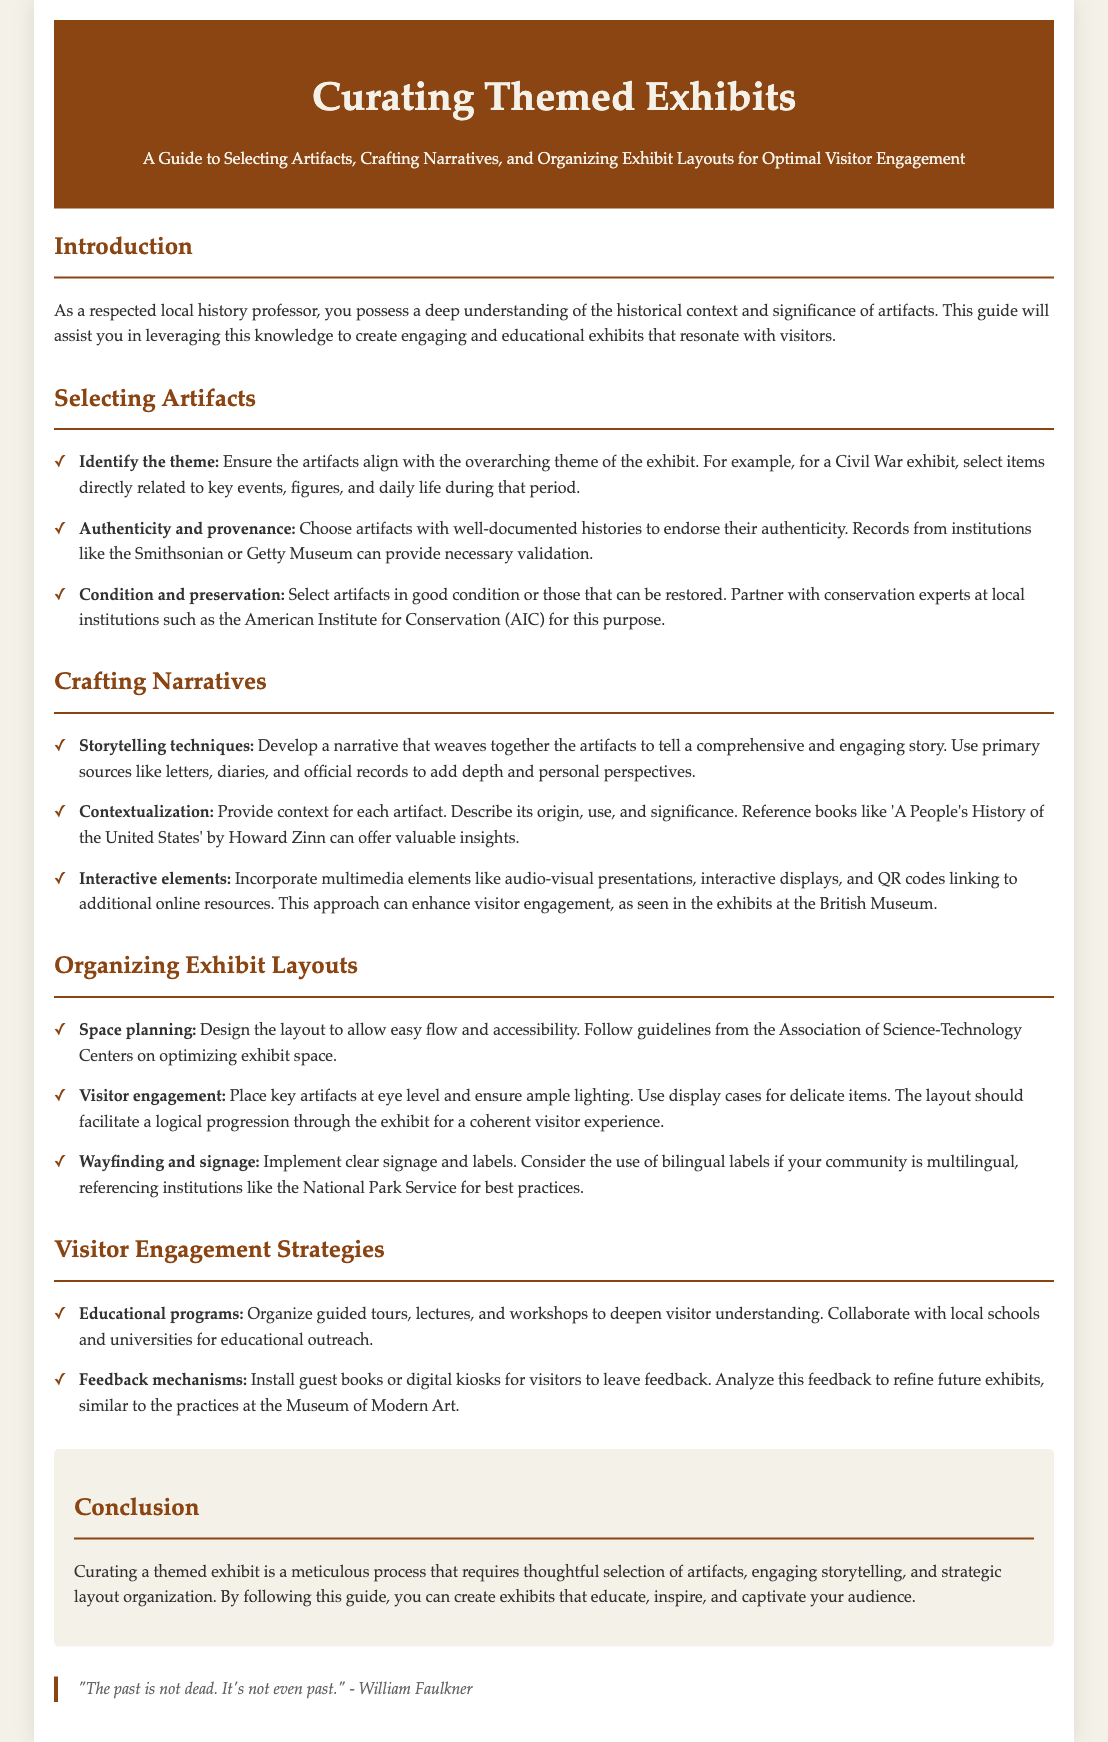what is the title of the guide? The title of the guide is the primary heading of the document, focusing on curating themed exhibits.
Answer: Curating Themed Exhibits what is one element to consider when selecting artifacts? The document lists several considerations for selecting artifacts, including authenticity, provenance, and condition.
Answer: Authenticity and provenance which author is referenced for insights on contextualization? The document mentions an author who wrote a related book for valuable insights into contextualizing artifacts.
Answer: Howard Zinn what type of strategies should be organized for visitor engagement? The document discusses various methods to enhance visitor engagement through educational efforts.
Answer: Educational programs what is the purpose of clear signage and labels? The guide explains the importance of signage in facilitating the exhibit's flow and understanding.
Answer: Wayfinding and signage how many key areas are emphasized in curating exhibits? The document outlines specific key areas involving artifacts, narratives, and layout organization in curating exhibits.
Answer: Three name one institution referenced for conservation expertise. The guide suggests partnering with specialized institutions for expert insights into artifact preservation.
Answer: American Institute for Conservation what is the concluding sentiment about curating exhibits? The conclusion captures the essence of the curating process, highlighting its importance in engaging audiences.
Answer: Educate, inspire, and captivate 